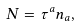Convert formula to latex. <formula><loc_0><loc_0><loc_500><loc_500>N = \tau ^ { a } n _ { a } ,</formula> 